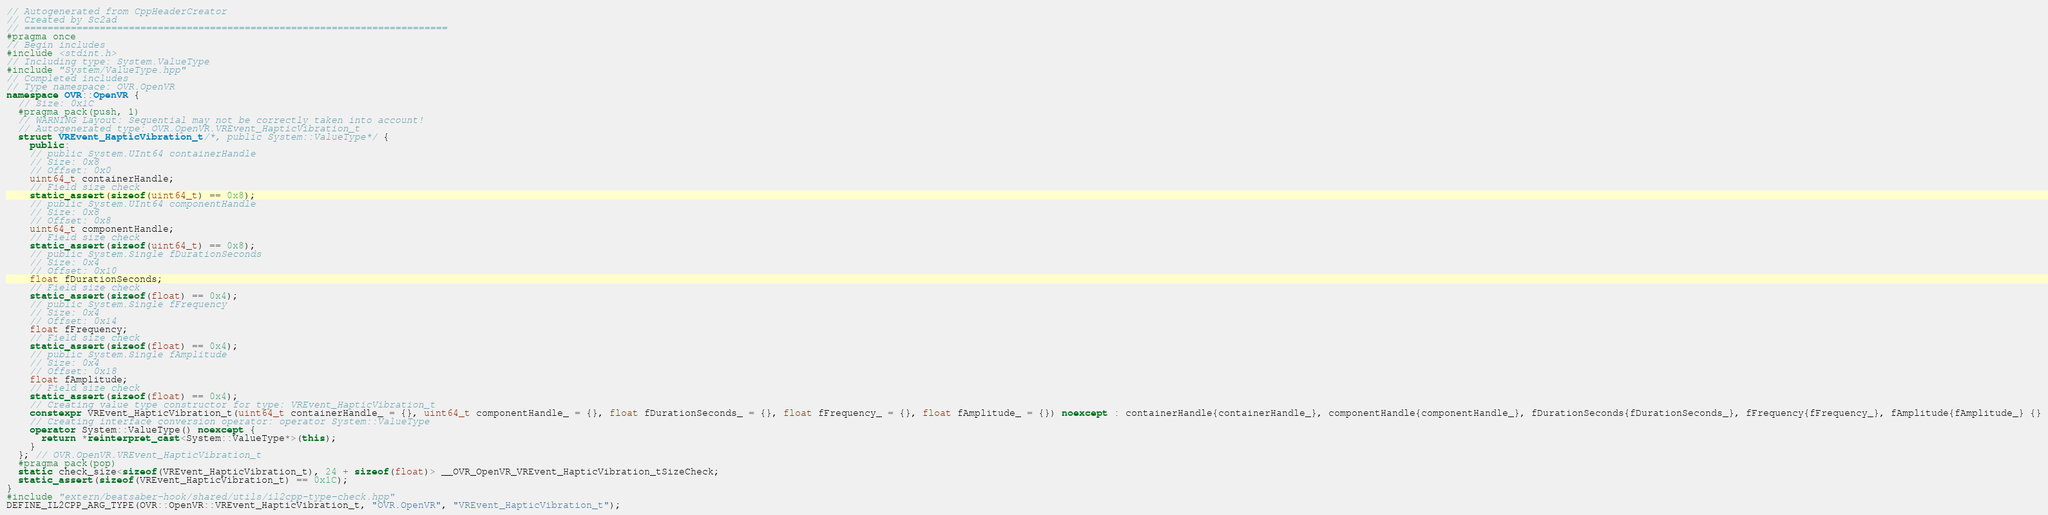Convert code to text. <code><loc_0><loc_0><loc_500><loc_500><_C++_>// Autogenerated from CppHeaderCreator
// Created by Sc2ad
// =========================================================================
#pragma once
// Begin includes
#include <stdint.h>
// Including type: System.ValueType
#include "System/ValueType.hpp"
// Completed includes
// Type namespace: OVR.OpenVR
namespace OVR::OpenVR {
  // Size: 0x1C
  #pragma pack(push, 1)
  // WARNING Layout: Sequential may not be correctly taken into account!
  // Autogenerated type: OVR.OpenVR.VREvent_HapticVibration_t
  struct VREvent_HapticVibration_t/*, public System::ValueType*/ {
    public:
    // public System.UInt64 containerHandle
    // Size: 0x8
    // Offset: 0x0
    uint64_t containerHandle;
    // Field size check
    static_assert(sizeof(uint64_t) == 0x8);
    // public System.UInt64 componentHandle
    // Size: 0x8
    // Offset: 0x8
    uint64_t componentHandle;
    // Field size check
    static_assert(sizeof(uint64_t) == 0x8);
    // public System.Single fDurationSeconds
    // Size: 0x4
    // Offset: 0x10
    float fDurationSeconds;
    // Field size check
    static_assert(sizeof(float) == 0x4);
    // public System.Single fFrequency
    // Size: 0x4
    // Offset: 0x14
    float fFrequency;
    // Field size check
    static_assert(sizeof(float) == 0x4);
    // public System.Single fAmplitude
    // Size: 0x4
    // Offset: 0x18
    float fAmplitude;
    // Field size check
    static_assert(sizeof(float) == 0x4);
    // Creating value type constructor for type: VREvent_HapticVibration_t
    constexpr VREvent_HapticVibration_t(uint64_t containerHandle_ = {}, uint64_t componentHandle_ = {}, float fDurationSeconds_ = {}, float fFrequency_ = {}, float fAmplitude_ = {}) noexcept : containerHandle{containerHandle_}, componentHandle{componentHandle_}, fDurationSeconds{fDurationSeconds_}, fFrequency{fFrequency_}, fAmplitude{fAmplitude_} {}
    // Creating interface conversion operator: operator System::ValueType
    operator System::ValueType() noexcept {
      return *reinterpret_cast<System::ValueType*>(this);
    }
  }; // OVR.OpenVR.VREvent_HapticVibration_t
  #pragma pack(pop)
  static check_size<sizeof(VREvent_HapticVibration_t), 24 + sizeof(float)> __OVR_OpenVR_VREvent_HapticVibration_tSizeCheck;
  static_assert(sizeof(VREvent_HapticVibration_t) == 0x1C);
}
#include "extern/beatsaber-hook/shared/utils/il2cpp-type-check.hpp"
DEFINE_IL2CPP_ARG_TYPE(OVR::OpenVR::VREvent_HapticVibration_t, "OVR.OpenVR", "VREvent_HapticVibration_t");
</code> 